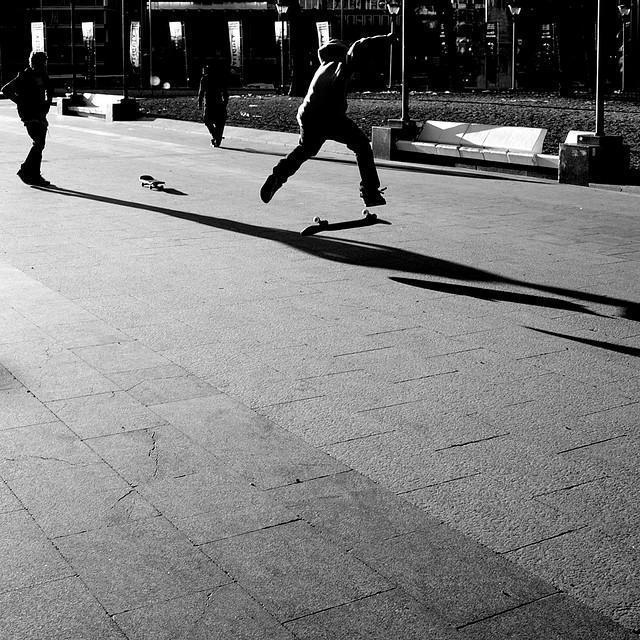How many people are in this picture?
Give a very brief answer. 3. How many blocks of white paint are there on the ground?
Give a very brief answer. 0. How many benches are there?
Give a very brief answer. 2. How many benches can you see?
Give a very brief answer. 1. How many people are visible?
Give a very brief answer. 2. How many airplanes are flying to the left of the person?
Give a very brief answer. 0. 